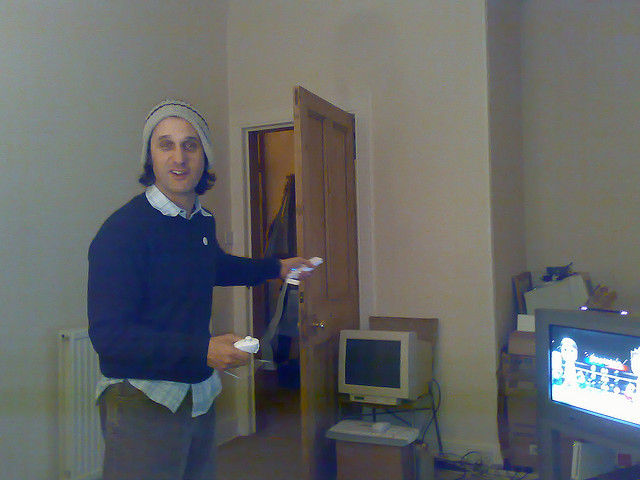<image>What brand of athletic shirt is this man wearing? I am not sure about the brand of the athletic shirt the man is wearing. It could be Ralph Lauren, Uni, Adidas, Nike or Izod. What kind of computer does he have? It is unknown what kind of computer he has. It could be a hp, apple ,old, pc, desktop or wii. What brand of athletic shirt is this man wearing? It is unknown what brand of athletic shirt the man is wearing. What kind of computer does he have? I don't know what kind of computer he has. It could be HP, Apple, PC, or desktop. 